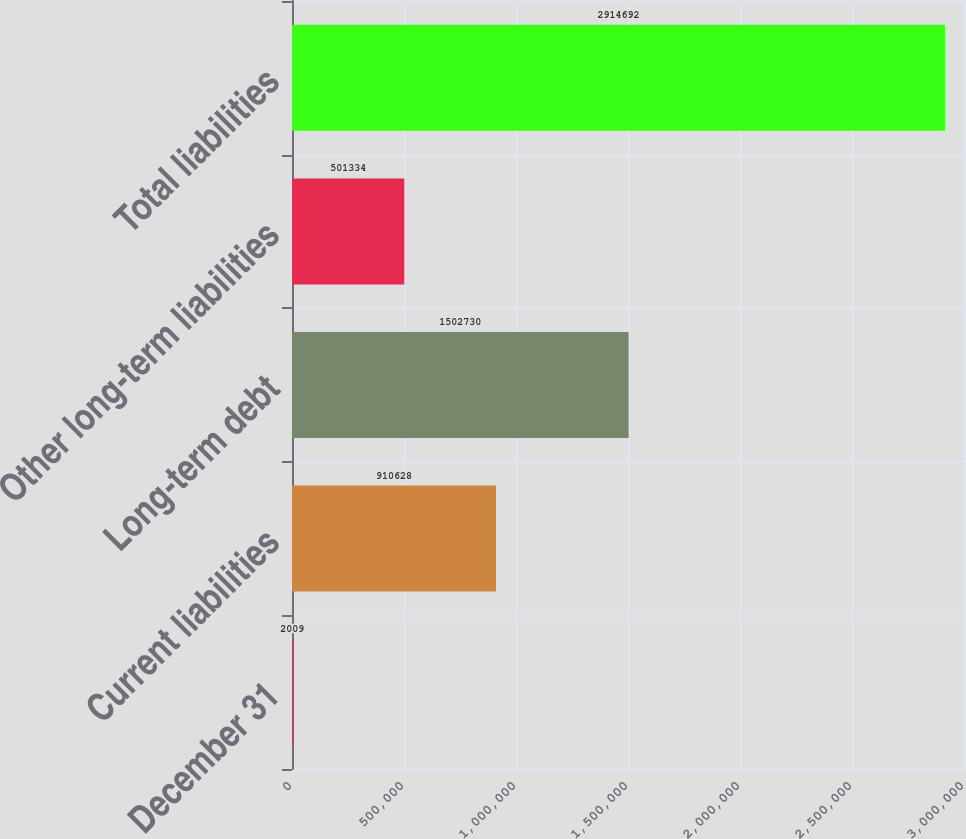<chart> <loc_0><loc_0><loc_500><loc_500><bar_chart><fcel>December 31<fcel>Current liabilities<fcel>Long-term debt<fcel>Other long-term liabilities<fcel>Total liabilities<nl><fcel>2009<fcel>910628<fcel>1.50273e+06<fcel>501334<fcel>2.91469e+06<nl></chart> 